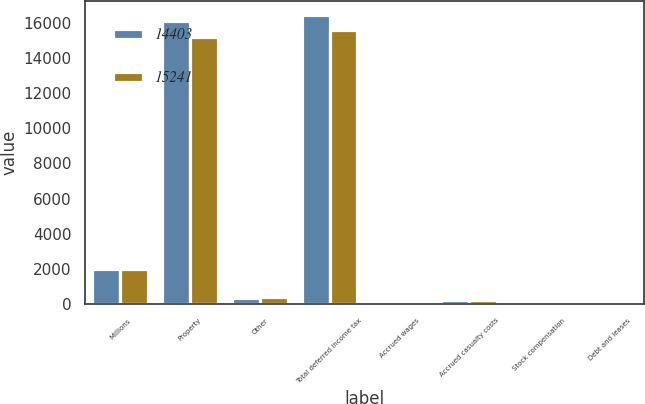<chart> <loc_0><loc_0><loc_500><loc_500><stacked_bar_chart><ecel><fcel>Millions<fcel>Property<fcel>Other<fcel>Total deferred income tax<fcel>Accrued wages<fcel>Accrued casualty costs<fcel>Stock compensation<fcel>Debt and leases<nl><fcel>14403<fcel>2015<fcel>16079<fcel>352<fcel>16431<fcel>76<fcel>237<fcel>72<fcel>149<nl><fcel>15241<fcel>2014<fcel>15173<fcel>411<fcel>15584<fcel>74<fcel>228<fcel>69<fcel>86<nl></chart> 